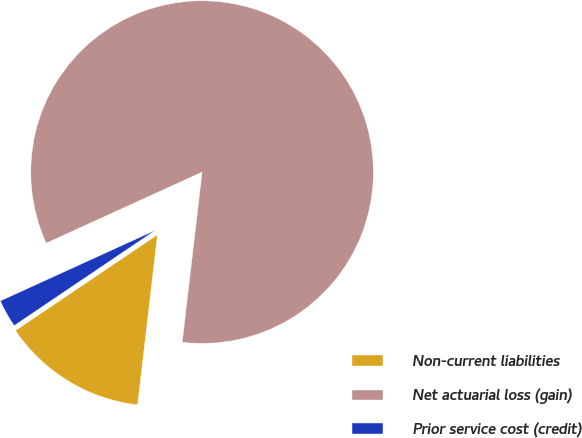Convert chart. <chart><loc_0><loc_0><loc_500><loc_500><pie_chart><fcel>Non-current liabilities<fcel>Net actuarial loss (gain)<fcel>Prior service cost (credit)<nl><fcel>13.7%<fcel>83.66%<fcel>2.64%<nl></chart> 